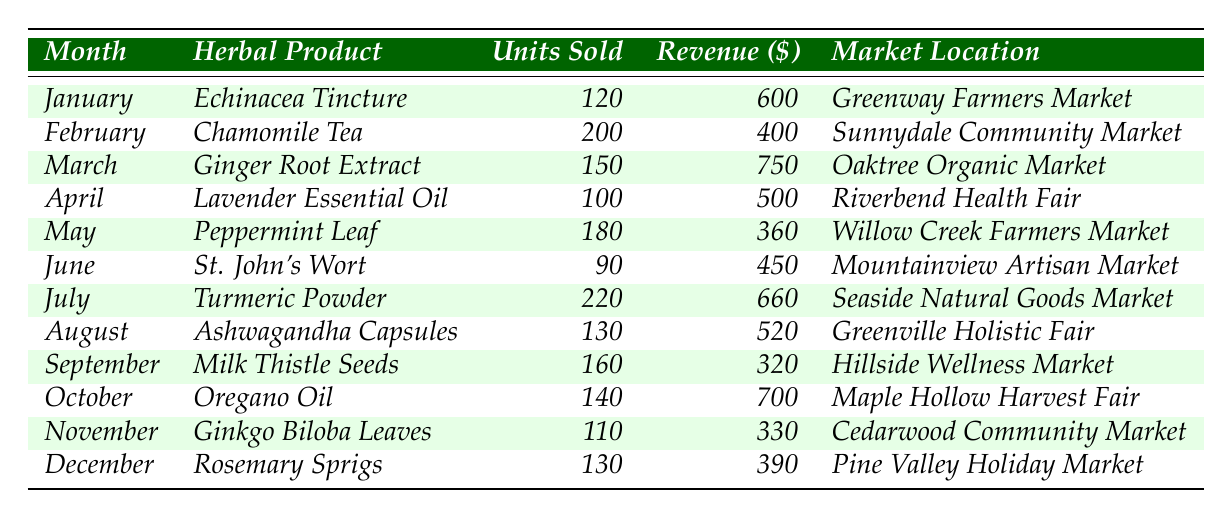What is the highest revenue generated by a single herbal product in a month? The maximum revenue in the table is found by examining each month's revenue. The highest revenue of $750 is from Ginger Root Extract in March.
Answer: $750 Which month had the lowest units sold and what was the product? By checking the "Units Sold" column, the lowest value is 90 units, which corresponds to St. John's Wort in June.
Answer: June, St. John's Wort What is the total revenue generated by herbal products during the first half of the year (January to June)? The total revenue is calculated by adding the revenue for each month from January to June: $600 (January) + $400 (February) + $750 (March) + $500 (April) + $360 (May) + $450 (June) = $3060.
Answer: $3060 Is it true that Lavender Essential Oil sold more units than Ginkgo Biloba Leaves? Comparing the units sold for both products: Lavender Essential Oil sold 100 units and Ginkgo Biloba Leaves sold 110 units. Therefore, it is false.
Answer: No Which market location recorded the highest units sold and how many were sold? By reviewing the table, Seaside Natural Goods Market in July had the highest units sold, with 220 units for Turmeric Powder.
Answer: Seaside Natural Goods Market, 220 units What was the average number of units sold per month across the entire year? To find the average, sum all units sold (120 + 200 + 150 + 100 + 180 + 90 + 220 + 130 + 160 + 140 + 110 + 130 = 1710) and divide by 12 months, resulting in an average of 142.5.
Answer: 142.5 In which month were more than 200 units sold, and what product was it? By reviewing the units sold per month, only July has more than 200 units sold; that product is Turmeric Powder with 220 units.
Answer: July, Turmeric Powder What is the total number of units sold in the second half of the year (July to December)? Adding the units sold from July to December: 220 (July) + 130 (August) + 160 (September) + 140 (October) + 110 (November) + 130 (December) = 990.
Answer: 990 Which product had a revenue of $320 and in which month was it sold? Looking through the revenue values, Milk Thistle Seeds generated $320 in September.
Answer: September, Milk Thistle Seeds How many herbal products generated a revenue of over $500? The products generating revenue over $500 are: Ginger Root Extract ($750 in March), and Oregano Oil ($700 in October), totaling 2 products.
Answer: 2 products 